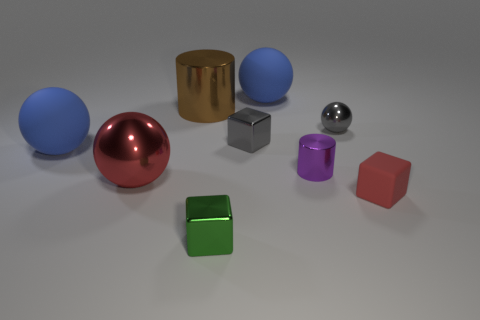Are there an equal number of blue objects that are left of the tiny green cube and big brown metallic objects that are in front of the small red block?
Make the answer very short. No. Do the matte thing that is in front of the small purple metal object and the tiny green shiny thing on the right side of the big shiny cylinder have the same shape?
Your answer should be compact. Yes. What shape is the green object that is made of the same material as the purple object?
Your answer should be very brief. Cube. Is the number of brown things behind the tiny rubber thing the same as the number of small cylinders?
Give a very brief answer. Yes. Are the red object that is to the left of the small matte thing and the blue sphere that is behind the large brown metallic object made of the same material?
Provide a short and direct response. No. The blue matte thing that is left of the blue sphere to the right of the tiny green shiny block is what shape?
Your response must be concise. Sphere. There is a tiny cylinder that is made of the same material as the big red sphere; what color is it?
Provide a short and direct response. Purple. Is the color of the large metallic ball the same as the small rubber thing?
Provide a short and direct response. Yes. The red metallic thing that is the same size as the brown metal object is what shape?
Ensure brevity in your answer.  Sphere. The purple cylinder is what size?
Your response must be concise. Small. 